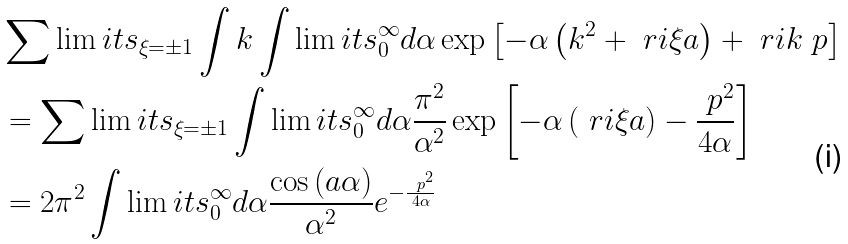Convert formula to latex. <formula><loc_0><loc_0><loc_500><loc_500>& \sum \lim i t s _ { \xi = \pm 1 } \int k \int \lim i t s _ { 0 } ^ { \infty } d \alpha \exp \left [ - \alpha \left ( k ^ { 2 } + \ r i \xi a \right ) + \ r i k \ p \right ] \\ & = \sum \lim i t s _ { \xi = \pm 1 } \int \lim i t s _ { 0 } ^ { \infty } d \alpha \frac { \pi ^ { 2 } } { \alpha ^ { 2 } } \exp \left [ - \alpha \left ( \ r i \xi a \right ) - \frac { \ p ^ { 2 } } { 4 \alpha } \right ] \\ & = 2 \pi ^ { 2 } \int \lim i t s _ { 0 } ^ { \infty } d \alpha \frac { \cos \left ( a \alpha \right ) } { \alpha ^ { 2 } } e ^ { - \frac { \ p ^ { 2 } } { 4 \alpha } }</formula> 